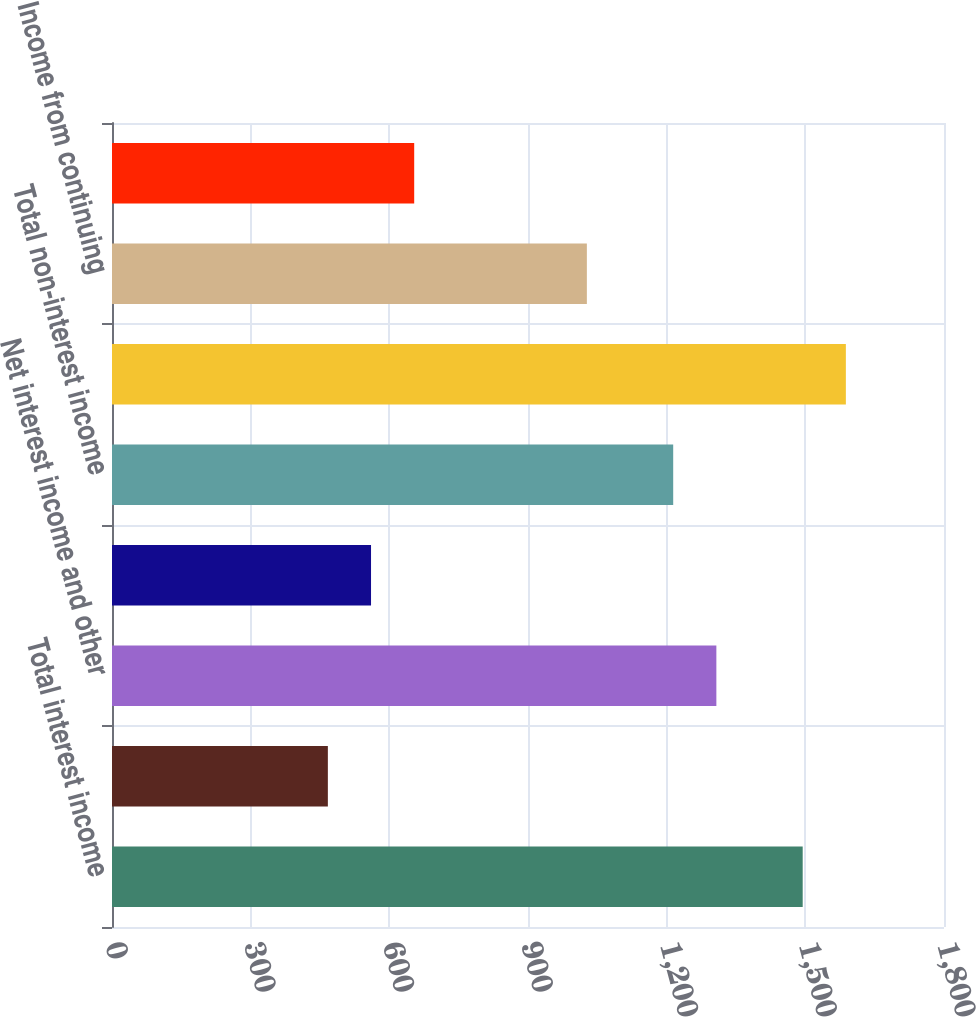Convert chart to OTSL. <chart><loc_0><loc_0><loc_500><loc_500><bar_chart><fcel>Total interest income<fcel>Total interest expense and<fcel>Net interest income and other<fcel>Provision for loan losses<fcel>Total non-interest income<fcel>Total non-interest expense<fcel>Income from continuing<fcel>Income tax expense<nl><fcel>1494.3<fcel>467.01<fcel>1307.52<fcel>560.4<fcel>1214.13<fcel>1587.69<fcel>1027.35<fcel>653.79<nl></chart> 